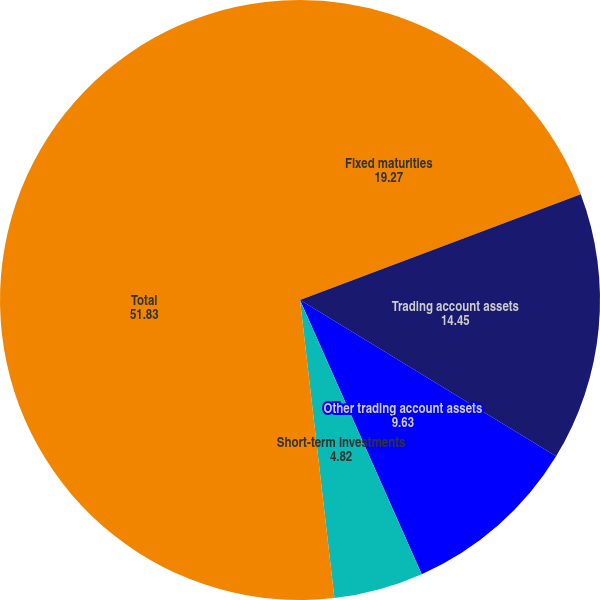Convert chart to OTSL. <chart><loc_0><loc_0><loc_500><loc_500><pie_chart><fcel>Fixed maturities<fcel>Trading account assets<fcel>Other trading account assets<fcel>Short-term investments<fcel>Cash equivalents<fcel>Total<nl><fcel>19.27%<fcel>14.45%<fcel>9.63%<fcel>4.82%<fcel>0.0%<fcel>51.83%<nl></chart> 